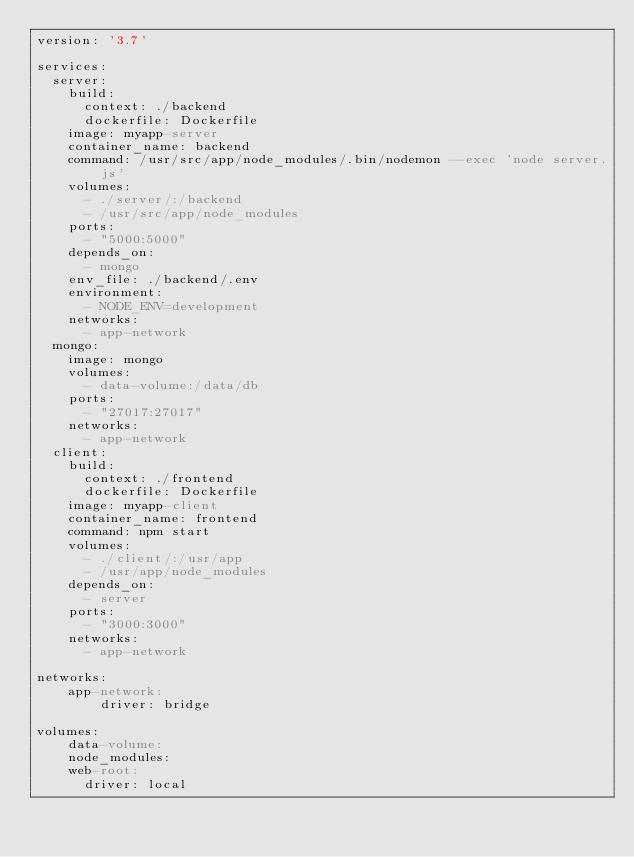Convert code to text. <code><loc_0><loc_0><loc_500><loc_500><_YAML_>version: '3.7'

services:
  server:
    build:
      context: ./backend
      dockerfile: Dockerfile
    image: myapp-server
    container_name: backend
    command: /usr/src/app/node_modules/.bin/nodemon --exec 'node server.js'
    volumes:
      - ./server/:/backend
      - /usr/src/app/node_modules
    ports:
      - "5000:5000"
    depends_on:
      - mongo
    env_file: ./backend/.env
    environment:
      - NODE_ENV=development
    networks:
      - app-network
  mongo:
    image: mongo
    volumes:
      - data-volume:/data/db
    ports:
      - "27017:27017"
    networks:
      - app-network
  client:
    build:
      context: ./frontend
      dockerfile: Dockerfile
    image: myapp-client
    container_name: frontend
    command: npm start
    volumes:
      - ./client/:/usr/app
      - /usr/app/node_modules
    depends_on:
      - server
    ports:
      - "3000:3000"
    networks:
      - app-network

networks:
    app-network:
        driver: bridge

volumes:
    data-volume:
    node_modules:
    web-root:
      driver: local</code> 